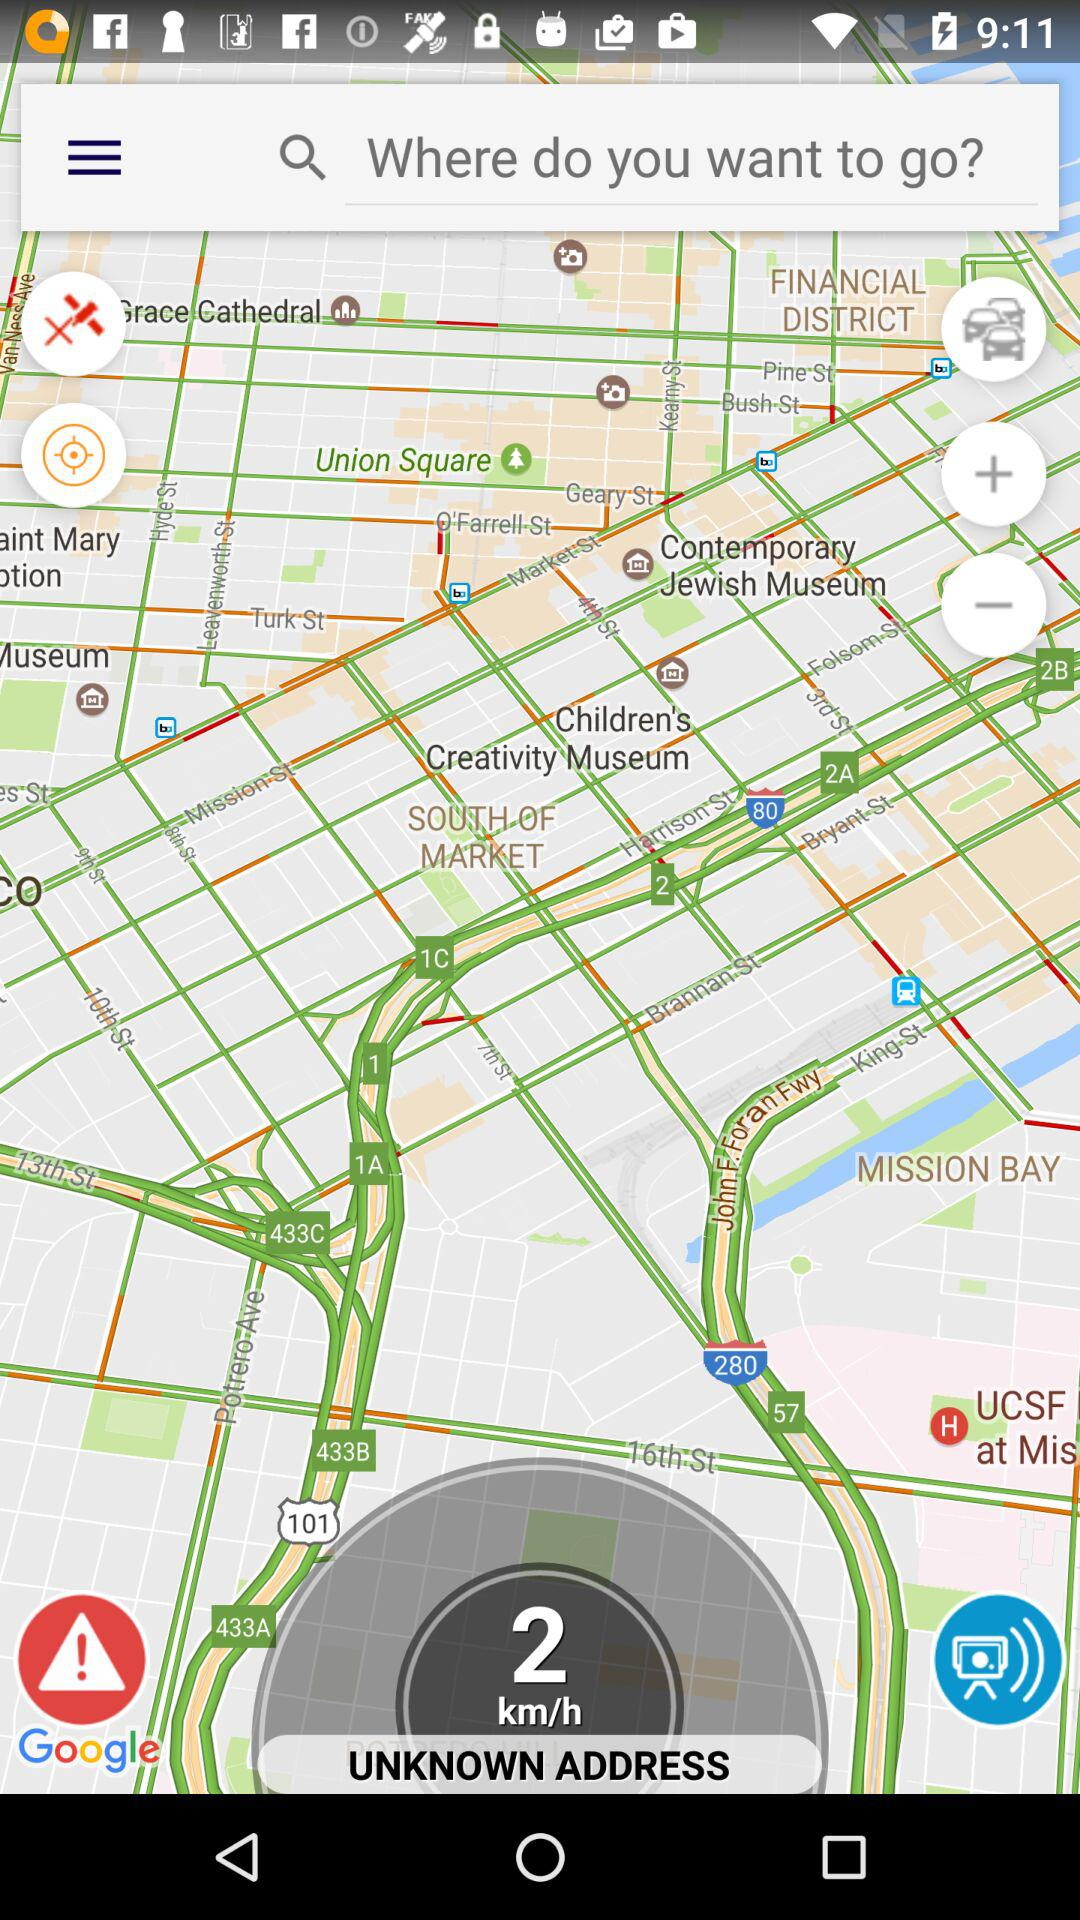What is the speed of the car in km/h?
Answer the question using a single word or phrase. 2 